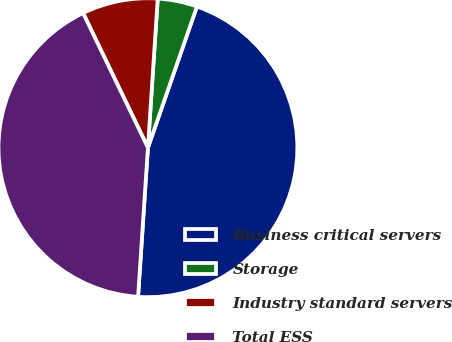Convert chart to OTSL. <chart><loc_0><loc_0><loc_500><loc_500><pie_chart><fcel>Business critical servers<fcel>Storage<fcel>Industry standard servers<fcel>Total ESS<nl><fcel>45.73%<fcel>4.27%<fcel>8.19%<fcel>41.81%<nl></chart> 